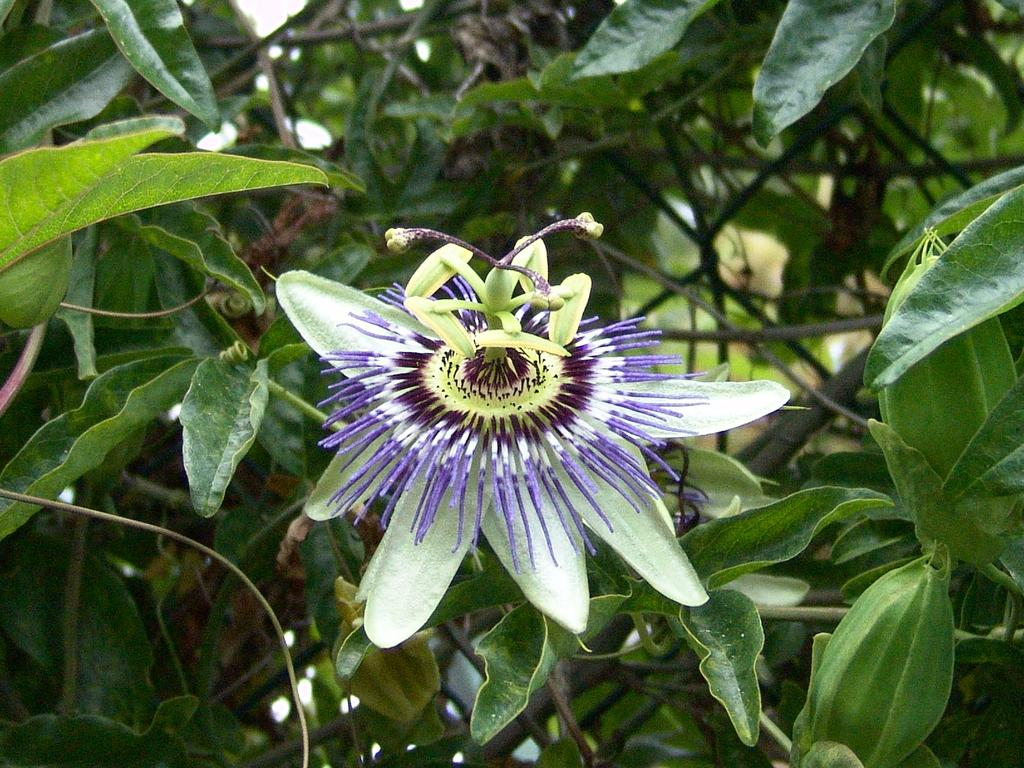What is the main subject of the image? There is a flower in the image. What can be seen in the background of the image? There are trees in the background of the image. What type of screw can be seen holding the border of the territory in the image? There is no screw, border, or territory present in the image; it features a flower and trees in the background. 